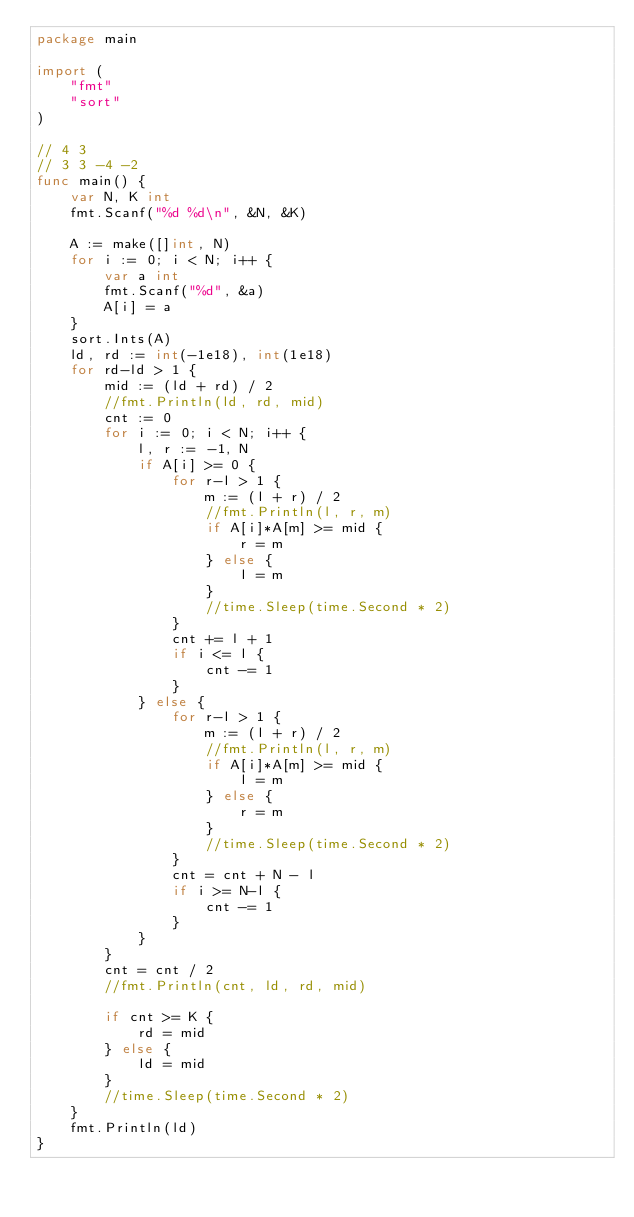Convert code to text. <code><loc_0><loc_0><loc_500><loc_500><_Go_>package main

import (
	"fmt"
	"sort"
)

// 4 3
// 3 3 -4 -2
func main() {
	var N, K int
	fmt.Scanf("%d %d\n", &N, &K)

	A := make([]int, N)
	for i := 0; i < N; i++ {
		var a int
		fmt.Scanf("%d", &a)
		A[i] = a
	}
	sort.Ints(A)
	ld, rd := int(-1e18), int(1e18)
	for rd-ld > 1 {
		mid := (ld + rd) / 2
		//fmt.Println(ld, rd, mid)
		cnt := 0
		for i := 0; i < N; i++ {
			l, r := -1, N
			if A[i] >= 0 {
				for r-l > 1 {
					m := (l + r) / 2
					//fmt.Println(l, r, m)
					if A[i]*A[m] >= mid {
						r = m
					} else {
						l = m
					}
					//time.Sleep(time.Second * 2)
				}
				cnt += l + 1
				if i <= l {
					cnt -= 1
				}
			} else {
				for r-l > 1 {
					m := (l + r) / 2
					//fmt.Println(l, r, m)
					if A[i]*A[m] >= mid {
						l = m
					} else {
						r = m
					}
					//time.Sleep(time.Second * 2)
				}
				cnt = cnt + N - l
				if i >= N-l {
					cnt -= 1
				}
			}
		}
		cnt = cnt / 2
		//fmt.Println(cnt, ld, rd, mid)

		if cnt >= K {
			rd = mid
		} else {
			ld = mid
		}
		//time.Sleep(time.Second * 2)
	}
	fmt.Println(ld)
}
</code> 